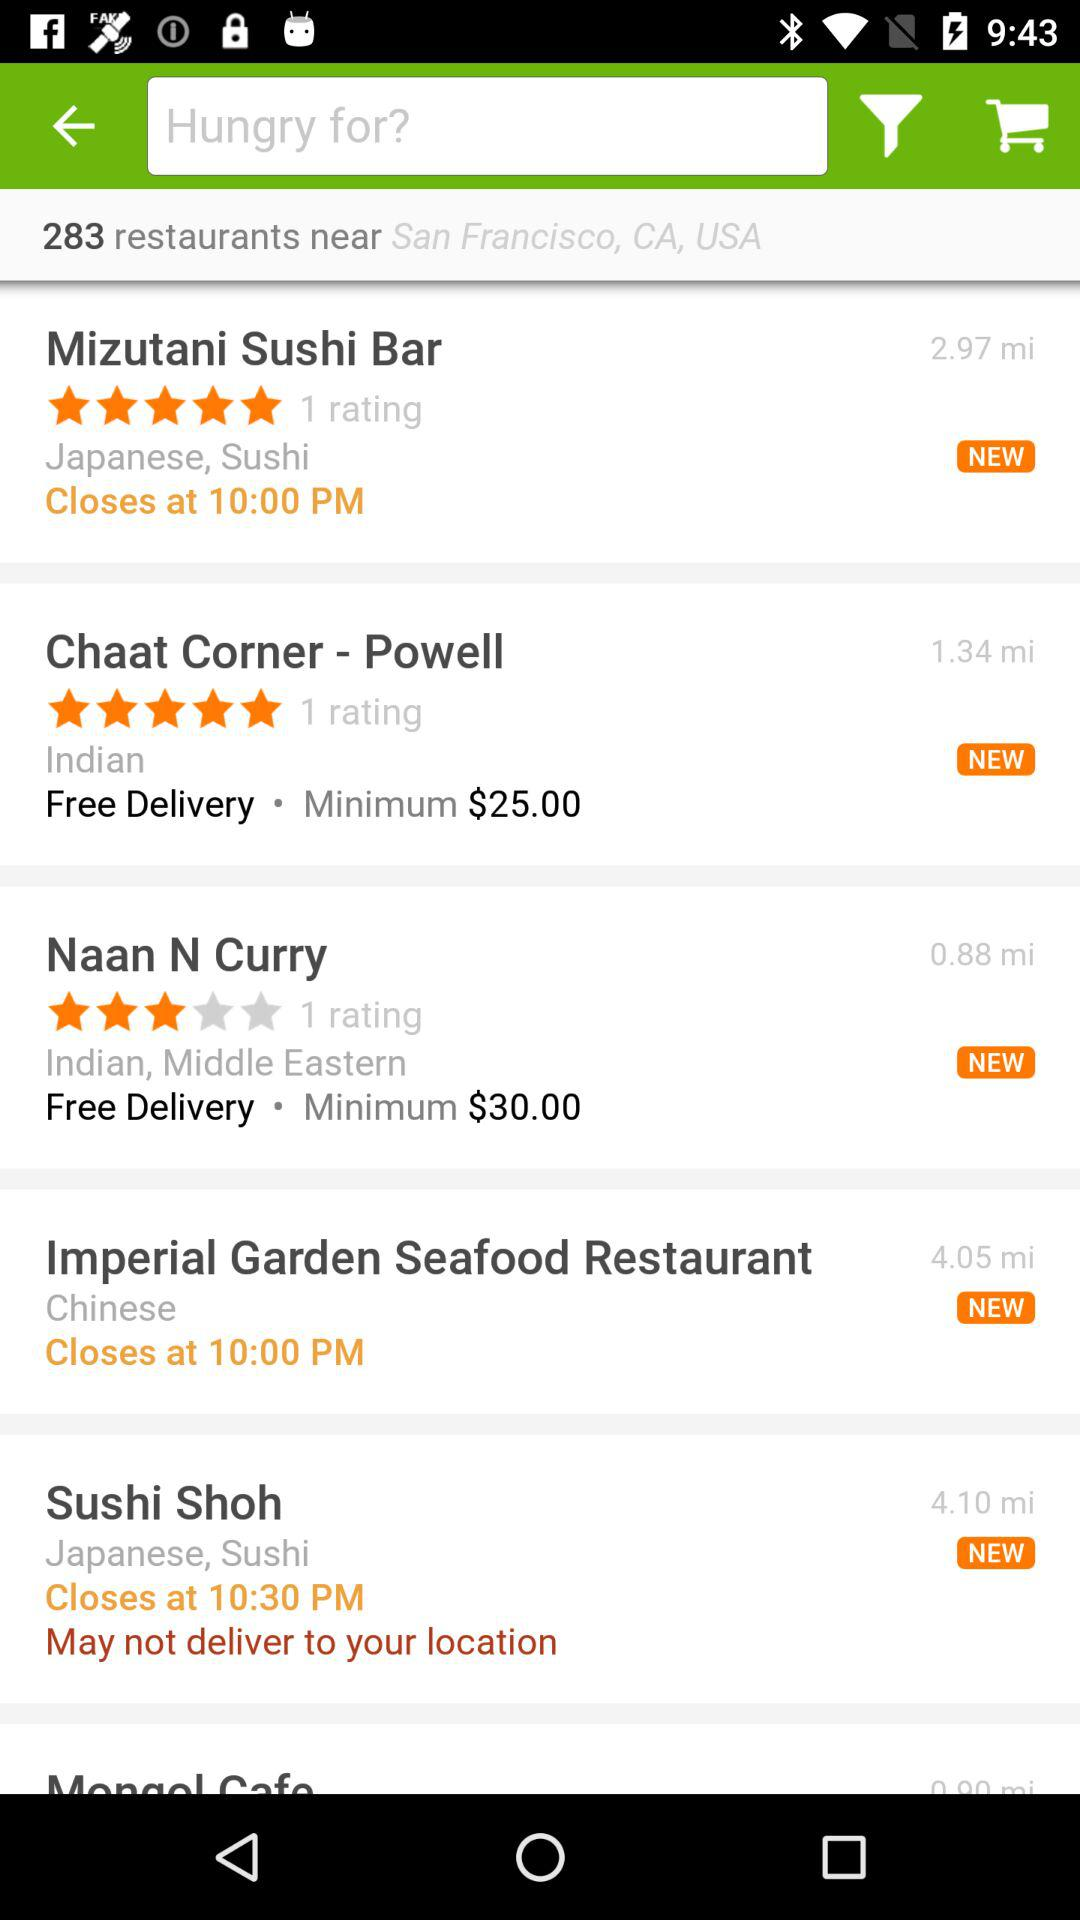Which restaurant does not give delivery to the selected location? The restaurant is "Sushi Shoh". 